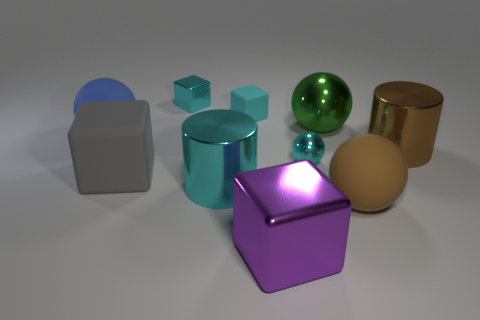How many other objects are the same material as the small cyan sphere?
Keep it short and to the point. 5. How many large blocks are behind the big brown ball and in front of the gray matte cube?
Ensure brevity in your answer.  0. Are there fewer small shiny objects on the right side of the cyan matte thing than blue matte balls?
Your answer should be very brief. No. Is there a gray metal block of the same size as the gray object?
Offer a terse response. No. There is a big sphere that is made of the same material as the brown cylinder; what is its color?
Make the answer very short. Green. There is a rubber ball on the left side of the brown rubber sphere; what number of rubber objects are behind it?
Offer a very short reply. 1. There is a small cyan object that is both right of the cyan shiny block and behind the blue matte sphere; what is its material?
Your response must be concise. Rubber. There is a green shiny object that is behind the large gray matte thing; is it the same shape as the large cyan shiny object?
Keep it short and to the point. No. Are there fewer big green metallic blocks than large green spheres?
Keep it short and to the point. Yes. How many small rubber objects are the same color as the tiny ball?
Keep it short and to the point. 1. 